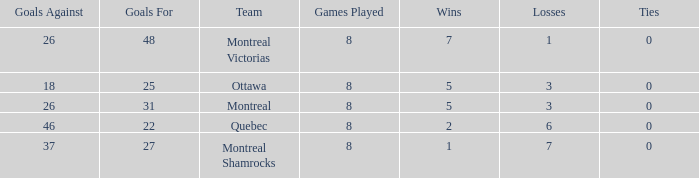For teams with more than 0 ties and goals against of 37, how many wins were tallied? None. 